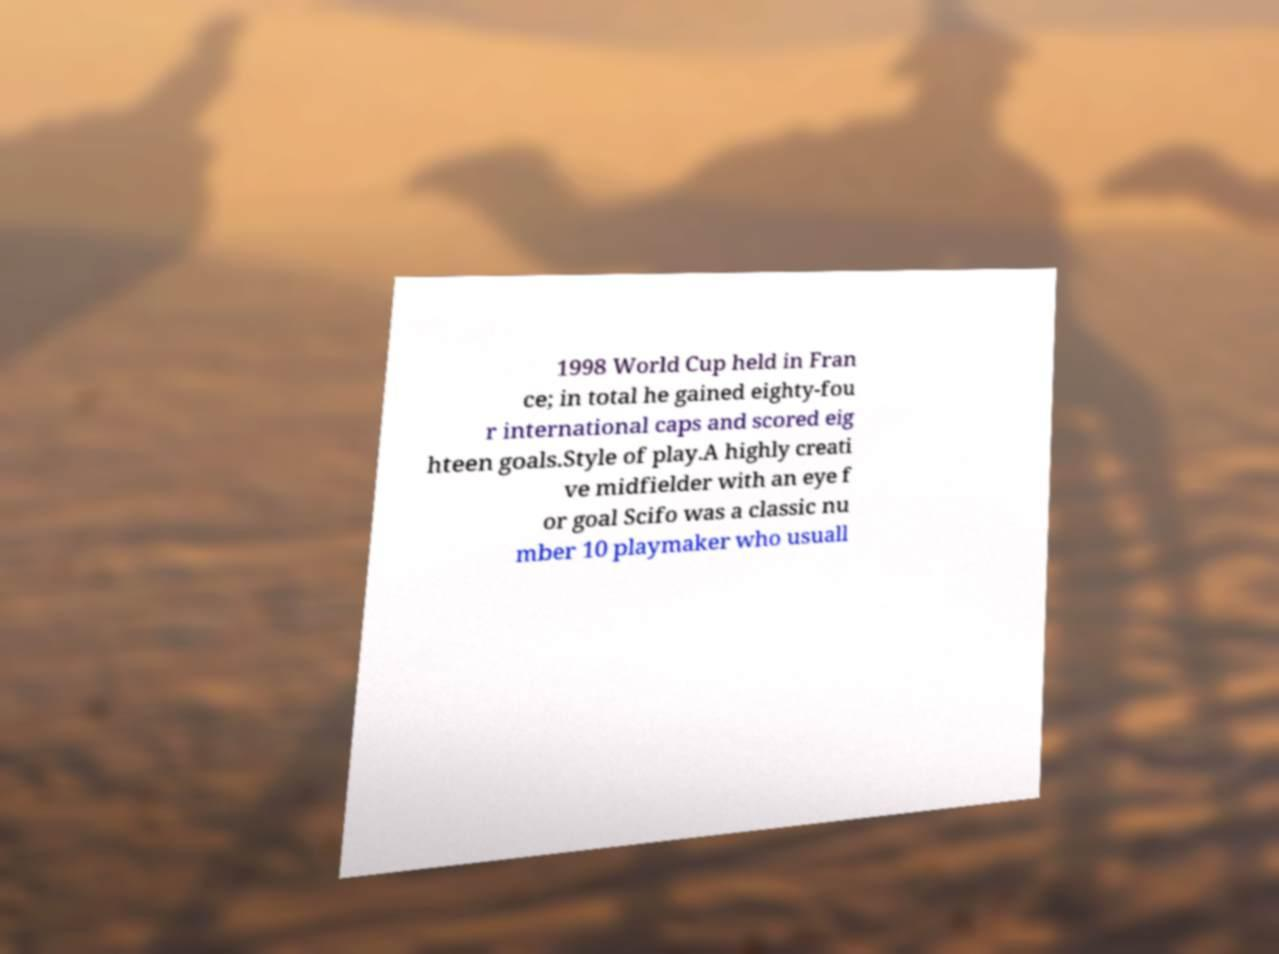There's text embedded in this image that I need extracted. Can you transcribe it verbatim? 1998 World Cup held in Fran ce; in total he gained eighty-fou r international caps and scored eig hteen goals.Style of play.A highly creati ve midfielder with an eye f or goal Scifo was a classic nu mber 10 playmaker who usuall 